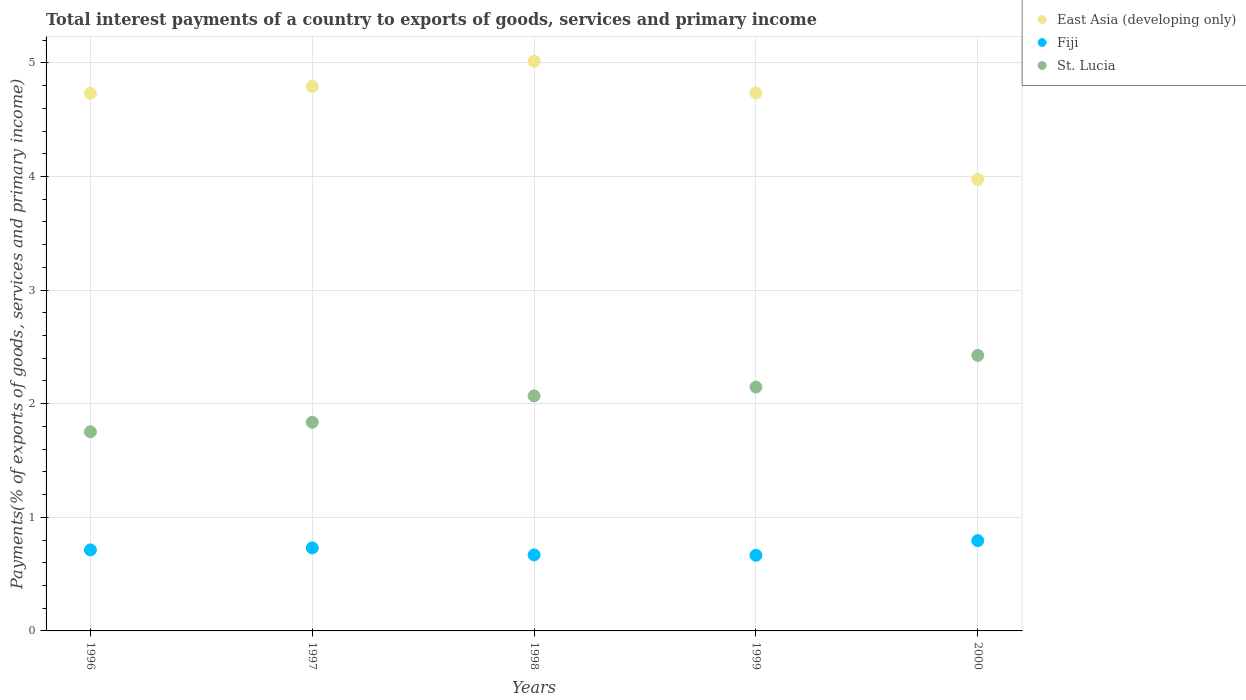What is the total interest payments in Fiji in 1996?
Your answer should be compact. 0.71. Across all years, what is the maximum total interest payments in Fiji?
Offer a very short reply. 0.79. Across all years, what is the minimum total interest payments in Fiji?
Your response must be concise. 0.67. In which year was the total interest payments in St. Lucia minimum?
Provide a short and direct response. 1996. What is the total total interest payments in Fiji in the graph?
Provide a succinct answer. 3.57. What is the difference between the total interest payments in St. Lucia in 1996 and that in 2000?
Your response must be concise. -0.67. What is the difference between the total interest payments in Fiji in 1998 and the total interest payments in St. Lucia in 1996?
Keep it short and to the point. -1.08. What is the average total interest payments in East Asia (developing only) per year?
Give a very brief answer. 4.65. In the year 1997, what is the difference between the total interest payments in East Asia (developing only) and total interest payments in Fiji?
Your answer should be compact. 4.06. What is the ratio of the total interest payments in East Asia (developing only) in 1996 to that in 1999?
Offer a very short reply. 1. Is the difference between the total interest payments in East Asia (developing only) in 1996 and 1999 greater than the difference between the total interest payments in Fiji in 1996 and 1999?
Ensure brevity in your answer.  No. What is the difference between the highest and the second highest total interest payments in Fiji?
Your answer should be very brief. 0.06. What is the difference between the highest and the lowest total interest payments in Fiji?
Your response must be concise. 0.13. In how many years, is the total interest payments in Fiji greater than the average total interest payments in Fiji taken over all years?
Your answer should be very brief. 2. Is it the case that in every year, the sum of the total interest payments in St. Lucia and total interest payments in East Asia (developing only)  is greater than the total interest payments in Fiji?
Your answer should be compact. Yes. Is the total interest payments in East Asia (developing only) strictly greater than the total interest payments in St. Lucia over the years?
Offer a terse response. Yes. How many dotlines are there?
Your answer should be very brief. 3. What is the difference between two consecutive major ticks on the Y-axis?
Your answer should be very brief. 1. Are the values on the major ticks of Y-axis written in scientific E-notation?
Make the answer very short. No. Does the graph contain any zero values?
Keep it short and to the point. No. Does the graph contain grids?
Offer a terse response. Yes. How many legend labels are there?
Make the answer very short. 3. What is the title of the graph?
Offer a terse response. Total interest payments of a country to exports of goods, services and primary income. Does "Low & middle income" appear as one of the legend labels in the graph?
Give a very brief answer. No. What is the label or title of the Y-axis?
Give a very brief answer. Payments(% of exports of goods, services and primary income). What is the Payments(% of exports of goods, services and primary income) in East Asia (developing only) in 1996?
Make the answer very short. 4.73. What is the Payments(% of exports of goods, services and primary income) of Fiji in 1996?
Provide a short and direct response. 0.71. What is the Payments(% of exports of goods, services and primary income) in St. Lucia in 1996?
Your answer should be compact. 1.75. What is the Payments(% of exports of goods, services and primary income) in East Asia (developing only) in 1997?
Offer a very short reply. 4.79. What is the Payments(% of exports of goods, services and primary income) in Fiji in 1997?
Your answer should be very brief. 0.73. What is the Payments(% of exports of goods, services and primary income) of St. Lucia in 1997?
Keep it short and to the point. 1.84. What is the Payments(% of exports of goods, services and primary income) of East Asia (developing only) in 1998?
Provide a succinct answer. 5.01. What is the Payments(% of exports of goods, services and primary income) in Fiji in 1998?
Provide a succinct answer. 0.67. What is the Payments(% of exports of goods, services and primary income) of St. Lucia in 1998?
Provide a short and direct response. 2.07. What is the Payments(% of exports of goods, services and primary income) of East Asia (developing only) in 1999?
Provide a short and direct response. 4.74. What is the Payments(% of exports of goods, services and primary income) in Fiji in 1999?
Offer a terse response. 0.67. What is the Payments(% of exports of goods, services and primary income) in St. Lucia in 1999?
Your answer should be compact. 2.15. What is the Payments(% of exports of goods, services and primary income) in East Asia (developing only) in 2000?
Ensure brevity in your answer.  3.97. What is the Payments(% of exports of goods, services and primary income) of Fiji in 2000?
Provide a succinct answer. 0.79. What is the Payments(% of exports of goods, services and primary income) in St. Lucia in 2000?
Offer a terse response. 2.43. Across all years, what is the maximum Payments(% of exports of goods, services and primary income) of East Asia (developing only)?
Provide a succinct answer. 5.01. Across all years, what is the maximum Payments(% of exports of goods, services and primary income) in Fiji?
Offer a very short reply. 0.79. Across all years, what is the maximum Payments(% of exports of goods, services and primary income) in St. Lucia?
Offer a very short reply. 2.43. Across all years, what is the minimum Payments(% of exports of goods, services and primary income) of East Asia (developing only)?
Provide a succinct answer. 3.97. Across all years, what is the minimum Payments(% of exports of goods, services and primary income) of Fiji?
Your answer should be compact. 0.67. Across all years, what is the minimum Payments(% of exports of goods, services and primary income) in St. Lucia?
Offer a terse response. 1.75. What is the total Payments(% of exports of goods, services and primary income) in East Asia (developing only) in the graph?
Ensure brevity in your answer.  23.25. What is the total Payments(% of exports of goods, services and primary income) in Fiji in the graph?
Provide a succinct answer. 3.57. What is the total Payments(% of exports of goods, services and primary income) of St. Lucia in the graph?
Your response must be concise. 10.23. What is the difference between the Payments(% of exports of goods, services and primary income) of East Asia (developing only) in 1996 and that in 1997?
Give a very brief answer. -0.06. What is the difference between the Payments(% of exports of goods, services and primary income) of Fiji in 1996 and that in 1997?
Make the answer very short. -0.02. What is the difference between the Payments(% of exports of goods, services and primary income) of St. Lucia in 1996 and that in 1997?
Give a very brief answer. -0.08. What is the difference between the Payments(% of exports of goods, services and primary income) in East Asia (developing only) in 1996 and that in 1998?
Make the answer very short. -0.28. What is the difference between the Payments(% of exports of goods, services and primary income) in Fiji in 1996 and that in 1998?
Your response must be concise. 0.04. What is the difference between the Payments(% of exports of goods, services and primary income) of St. Lucia in 1996 and that in 1998?
Ensure brevity in your answer.  -0.32. What is the difference between the Payments(% of exports of goods, services and primary income) in East Asia (developing only) in 1996 and that in 1999?
Make the answer very short. -0. What is the difference between the Payments(% of exports of goods, services and primary income) in Fiji in 1996 and that in 1999?
Your response must be concise. 0.05. What is the difference between the Payments(% of exports of goods, services and primary income) in St. Lucia in 1996 and that in 1999?
Your answer should be very brief. -0.39. What is the difference between the Payments(% of exports of goods, services and primary income) in East Asia (developing only) in 1996 and that in 2000?
Give a very brief answer. 0.76. What is the difference between the Payments(% of exports of goods, services and primary income) in Fiji in 1996 and that in 2000?
Ensure brevity in your answer.  -0.08. What is the difference between the Payments(% of exports of goods, services and primary income) of St. Lucia in 1996 and that in 2000?
Your response must be concise. -0.67. What is the difference between the Payments(% of exports of goods, services and primary income) in East Asia (developing only) in 1997 and that in 1998?
Ensure brevity in your answer.  -0.22. What is the difference between the Payments(% of exports of goods, services and primary income) in Fiji in 1997 and that in 1998?
Your answer should be compact. 0.06. What is the difference between the Payments(% of exports of goods, services and primary income) of St. Lucia in 1997 and that in 1998?
Ensure brevity in your answer.  -0.23. What is the difference between the Payments(% of exports of goods, services and primary income) of East Asia (developing only) in 1997 and that in 1999?
Offer a terse response. 0.06. What is the difference between the Payments(% of exports of goods, services and primary income) of Fiji in 1997 and that in 1999?
Provide a short and direct response. 0.07. What is the difference between the Payments(% of exports of goods, services and primary income) of St. Lucia in 1997 and that in 1999?
Your answer should be very brief. -0.31. What is the difference between the Payments(% of exports of goods, services and primary income) in East Asia (developing only) in 1997 and that in 2000?
Keep it short and to the point. 0.82. What is the difference between the Payments(% of exports of goods, services and primary income) of Fiji in 1997 and that in 2000?
Give a very brief answer. -0.06. What is the difference between the Payments(% of exports of goods, services and primary income) of St. Lucia in 1997 and that in 2000?
Your response must be concise. -0.59. What is the difference between the Payments(% of exports of goods, services and primary income) in East Asia (developing only) in 1998 and that in 1999?
Your response must be concise. 0.28. What is the difference between the Payments(% of exports of goods, services and primary income) in Fiji in 1998 and that in 1999?
Give a very brief answer. 0. What is the difference between the Payments(% of exports of goods, services and primary income) in St. Lucia in 1998 and that in 1999?
Your response must be concise. -0.08. What is the difference between the Payments(% of exports of goods, services and primary income) in East Asia (developing only) in 1998 and that in 2000?
Give a very brief answer. 1.04. What is the difference between the Payments(% of exports of goods, services and primary income) in Fiji in 1998 and that in 2000?
Your response must be concise. -0.13. What is the difference between the Payments(% of exports of goods, services and primary income) in St. Lucia in 1998 and that in 2000?
Keep it short and to the point. -0.36. What is the difference between the Payments(% of exports of goods, services and primary income) of East Asia (developing only) in 1999 and that in 2000?
Your response must be concise. 0.76. What is the difference between the Payments(% of exports of goods, services and primary income) of Fiji in 1999 and that in 2000?
Ensure brevity in your answer.  -0.13. What is the difference between the Payments(% of exports of goods, services and primary income) in St. Lucia in 1999 and that in 2000?
Your answer should be compact. -0.28. What is the difference between the Payments(% of exports of goods, services and primary income) of East Asia (developing only) in 1996 and the Payments(% of exports of goods, services and primary income) of Fiji in 1997?
Your response must be concise. 4. What is the difference between the Payments(% of exports of goods, services and primary income) of East Asia (developing only) in 1996 and the Payments(% of exports of goods, services and primary income) of St. Lucia in 1997?
Ensure brevity in your answer.  2.9. What is the difference between the Payments(% of exports of goods, services and primary income) of Fiji in 1996 and the Payments(% of exports of goods, services and primary income) of St. Lucia in 1997?
Provide a succinct answer. -1.12. What is the difference between the Payments(% of exports of goods, services and primary income) in East Asia (developing only) in 1996 and the Payments(% of exports of goods, services and primary income) in Fiji in 1998?
Keep it short and to the point. 4.06. What is the difference between the Payments(% of exports of goods, services and primary income) of East Asia (developing only) in 1996 and the Payments(% of exports of goods, services and primary income) of St. Lucia in 1998?
Your response must be concise. 2.66. What is the difference between the Payments(% of exports of goods, services and primary income) of Fiji in 1996 and the Payments(% of exports of goods, services and primary income) of St. Lucia in 1998?
Your response must be concise. -1.36. What is the difference between the Payments(% of exports of goods, services and primary income) of East Asia (developing only) in 1996 and the Payments(% of exports of goods, services and primary income) of Fiji in 1999?
Offer a terse response. 4.07. What is the difference between the Payments(% of exports of goods, services and primary income) of East Asia (developing only) in 1996 and the Payments(% of exports of goods, services and primary income) of St. Lucia in 1999?
Your answer should be very brief. 2.59. What is the difference between the Payments(% of exports of goods, services and primary income) in Fiji in 1996 and the Payments(% of exports of goods, services and primary income) in St. Lucia in 1999?
Provide a succinct answer. -1.43. What is the difference between the Payments(% of exports of goods, services and primary income) in East Asia (developing only) in 1996 and the Payments(% of exports of goods, services and primary income) in Fiji in 2000?
Offer a very short reply. 3.94. What is the difference between the Payments(% of exports of goods, services and primary income) in East Asia (developing only) in 1996 and the Payments(% of exports of goods, services and primary income) in St. Lucia in 2000?
Provide a succinct answer. 2.31. What is the difference between the Payments(% of exports of goods, services and primary income) in Fiji in 1996 and the Payments(% of exports of goods, services and primary income) in St. Lucia in 2000?
Your answer should be very brief. -1.71. What is the difference between the Payments(% of exports of goods, services and primary income) in East Asia (developing only) in 1997 and the Payments(% of exports of goods, services and primary income) in Fiji in 1998?
Offer a very short reply. 4.12. What is the difference between the Payments(% of exports of goods, services and primary income) of East Asia (developing only) in 1997 and the Payments(% of exports of goods, services and primary income) of St. Lucia in 1998?
Keep it short and to the point. 2.72. What is the difference between the Payments(% of exports of goods, services and primary income) in Fiji in 1997 and the Payments(% of exports of goods, services and primary income) in St. Lucia in 1998?
Ensure brevity in your answer.  -1.34. What is the difference between the Payments(% of exports of goods, services and primary income) in East Asia (developing only) in 1997 and the Payments(% of exports of goods, services and primary income) in Fiji in 1999?
Ensure brevity in your answer.  4.13. What is the difference between the Payments(% of exports of goods, services and primary income) in East Asia (developing only) in 1997 and the Payments(% of exports of goods, services and primary income) in St. Lucia in 1999?
Ensure brevity in your answer.  2.65. What is the difference between the Payments(% of exports of goods, services and primary income) in Fiji in 1997 and the Payments(% of exports of goods, services and primary income) in St. Lucia in 1999?
Your answer should be compact. -1.42. What is the difference between the Payments(% of exports of goods, services and primary income) of East Asia (developing only) in 1997 and the Payments(% of exports of goods, services and primary income) of Fiji in 2000?
Your answer should be very brief. 4. What is the difference between the Payments(% of exports of goods, services and primary income) in East Asia (developing only) in 1997 and the Payments(% of exports of goods, services and primary income) in St. Lucia in 2000?
Provide a succinct answer. 2.37. What is the difference between the Payments(% of exports of goods, services and primary income) of Fiji in 1997 and the Payments(% of exports of goods, services and primary income) of St. Lucia in 2000?
Give a very brief answer. -1.69. What is the difference between the Payments(% of exports of goods, services and primary income) of East Asia (developing only) in 1998 and the Payments(% of exports of goods, services and primary income) of Fiji in 1999?
Give a very brief answer. 4.35. What is the difference between the Payments(% of exports of goods, services and primary income) of East Asia (developing only) in 1998 and the Payments(% of exports of goods, services and primary income) of St. Lucia in 1999?
Give a very brief answer. 2.87. What is the difference between the Payments(% of exports of goods, services and primary income) in Fiji in 1998 and the Payments(% of exports of goods, services and primary income) in St. Lucia in 1999?
Provide a short and direct response. -1.48. What is the difference between the Payments(% of exports of goods, services and primary income) in East Asia (developing only) in 1998 and the Payments(% of exports of goods, services and primary income) in Fiji in 2000?
Provide a succinct answer. 4.22. What is the difference between the Payments(% of exports of goods, services and primary income) in East Asia (developing only) in 1998 and the Payments(% of exports of goods, services and primary income) in St. Lucia in 2000?
Make the answer very short. 2.59. What is the difference between the Payments(% of exports of goods, services and primary income) of Fiji in 1998 and the Payments(% of exports of goods, services and primary income) of St. Lucia in 2000?
Your answer should be compact. -1.76. What is the difference between the Payments(% of exports of goods, services and primary income) of East Asia (developing only) in 1999 and the Payments(% of exports of goods, services and primary income) of Fiji in 2000?
Your answer should be very brief. 3.94. What is the difference between the Payments(% of exports of goods, services and primary income) in East Asia (developing only) in 1999 and the Payments(% of exports of goods, services and primary income) in St. Lucia in 2000?
Your answer should be very brief. 2.31. What is the difference between the Payments(% of exports of goods, services and primary income) in Fiji in 1999 and the Payments(% of exports of goods, services and primary income) in St. Lucia in 2000?
Your answer should be very brief. -1.76. What is the average Payments(% of exports of goods, services and primary income) in East Asia (developing only) per year?
Your answer should be compact. 4.65. What is the average Payments(% of exports of goods, services and primary income) of Fiji per year?
Ensure brevity in your answer.  0.71. What is the average Payments(% of exports of goods, services and primary income) of St. Lucia per year?
Provide a succinct answer. 2.05. In the year 1996, what is the difference between the Payments(% of exports of goods, services and primary income) in East Asia (developing only) and Payments(% of exports of goods, services and primary income) in Fiji?
Your answer should be very brief. 4.02. In the year 1996, what is the difference between the Payments(% of exports of goods, services and primary income) in East Asia (developing only) and Payments(% of exports of goods, services and primary income) in St. Lucia?
Your response must be concise. 2.98. In the year 1996, what is the difference between the Payments(% of exports of goods, services and primary income) of Fiji and Payments(% of exports of goods, services and primary income) of St. Lucia?
Provide a succinct answer. -1.04. In the year 1997, what is the difference between the Payments(% of exports of goods, services and primary income) of East Asia (developing only) and Payments(% of exports of goods, services and primary income) of Fiji?
Your answer should be very brief. 4.06. In the year 1997, what is the difference between the Payments(% of exports of goods, services and primary income) in East Asia (developing only) and Payments(% of exports of goods, services and primary income) in St. Lucia?
Keep it short and to the point. 2.96. In the year 1997, what is the difference between the Payments(% of exports of goods, services and primary income) of Fiji and Payments(% of exports of goods, services and primary income) of St. Lucia?
Offer a very short reply. -1.11. In the year 1998, what is the difference between the Payments(% of exports of goods, services and primary income) of East Asia (developing only) and Payments(% of exports of goods, services and primary income) of Fiji?
Your answer should be very brief. 4.35. In the year 1998, what is the difference between the Payments(% of exports of goods, services and primary income) of East Asia (developing only) and Payments(% of exports of goods, services and primary income) of St. Lucia?
Offer a terse response. 2.95. In the year 1998, what is the difference between the Payments(% of exports of goods, services and primary income) of Fiji and Payments(% of exports of goods, services and primary income) of St. Lucia?
Provide a short and direct response. -1.4. In the year 1999, what is the difference between the Payments(% of exports of goods, services and primary income) in East Asia (developing only) and Payments(% of exports of goods, services and primary income) in Fiji?
Keep it short and to the point. 4.07. In the year 1999, what is the difference between the Payments(% of exports of goods, services and primary income) in East Asia (developing only) and Payments(% of exports of goods, services and primary income) in St. Lucia?
Provide a short and direct response. 2.59. In the year 1999, what is the difference between the Payments(% of exports of goods, services and primary income) in Fiji and Payments(% of exports of goods, services and primary income) in St. Lucia?
Offer a very short reply. -1.48. In the year 2000, what is the difference between the Payments(% of exports of goods, services and primary income) in East Asia (developing only) and Payments(% of exports of goods, services and primary income) in Fiji?
Give a very brief answer. 3.18. In the year 2000, what is the difference between the Payments(% of exports of goods, services and primary income) in East Asia (developing only) and Payments(% of exports of goods, services and primary income) in St. Lucia?
Ensure brevity in your answer.  1.55. In the year 2000, what is the difference between the Payments(% of exports of goods, services and primary income) in Fiji and Payments(% of exports of goods, services and primary income) in St. Lucia?
Offer a terse response. -1.63. What is the ratio of the Payments(% of exports of goods, services and primary income) of East Asia (developing only) in 1996 to that in 1997?
Give a very brief answer. 0.99. What is the ratio of the Payments(% of exports of goods, services and primary income) in Fiji in 1996 to that in 1997?
Your response must be concise. 0.98. What is the ratio of the Payments(% of exports of goods, services and primary income) in St. Lucia in 1996 to that in 1997?
Provide a short and direct response. 0.95. What is the ratio of the Payments(% of exports of goods, services and primary income) in East Asia (developing only) in 1996 to that in 1998?
Offer a terse response. 0.94. What is the ratio of the Payments(% of exports of goods, services and primary income) of Fiji in 1996 to that in 1998?
Give a very brief answer. 1.07. What is the ratio of the Payments(% of exports of goods, services and primary income) of St. Lucia in 1996 to that in 1998?
Your answer should be compact. 0.85. What is the ratio of the Payments(% of exports of goods, services and primary income) in Fiji in 1996 to that in 1999?
Provide a succinct answer. 1.07. What is the ratio of the Payments(% of exports of goods, services and primary income) in St. Lucia in 1996 to that in 1999?
Offer a very short reply. 0.82. What is the ratio of the Payments(% of exports of goods, services and primary income) in East Asia (developing only) in 1996 to that in 2000?
Keep it short and to the point. 1.19. What is the ratio of the Payments(% of exports of goods, services and primary income) of Fiji in 1996 to that in 2000?
Provide a succinct answer. 0.9. What is the ratio of the Payments(% of exports of goods, services and primary income) in St. Lucia in 1996 to that in 2000?
Keep it short and to the point. 0.72. What is the ratio of the Payments(% of exports of goods, services and primary income) of East Asia (developing only) in 1997 to that in 1998?
Your answer should be very brief. 0.96. What is the ratio of the Payments(% of exports of goods, services and primary income) of Fiji in 1997 to that in 1998?
Ensure brevity in your answer.  1.09. What is the ratio of the Payments(% of exports of goods, services and primary income) in St. Lucia in 1997 to that in 1998?
Your answer should be compact. 0.89. What is the ratio of the Payments(% of exports of goods, services and primary income) of Fiji in 1997 to that in 1999?
Make the answer very short. 1.1. What is the ratio of the Payments(% of exports of goods, services and primary income) of St. Lucia in 1997 to that in 1999?
Your answer should be very brief. 0.86. What is the ratio of the Payments(% of exports of goods, services and primary income) of East Asia (developing only) in 1997 to that in 2000?
Ensure brevity in your answer.  1.21. What is the ratio of the Payments(% of exports of goods, services and primary income) in Fiji in 1997 to that in 2000?
Make the answer very short. 0.92. What is the ratio of the Payments(% of exports of goods, services and primary income) in St. Lucia in 1997 to that in 2000?
Your answer should be very brief. 0.76. What is the ratio of the Payments(% of exports of goods, services and primary income) in East Asia (developing only) in 1998 to that in 1999?
Provide a succinct answer. 1.06. What is the ratio of the Payments(% of exports of goods, services and primary income) of Fiji in 1998 to that in 1999?
Make the answer very short. 1. What is the ratio of the Payments(% of exports of goods, services and primary income) of St. Lucia in 1998 to that in 1999?
Your answer should be very brief. 0.96. What is the ratio of the Payments(% of exports of goods, services and primary income) in East Asia (developing only) in 1998 to that in 2000?
Provide a succinct answer. 1.26. What is the ratio of the Payments(% of exports of goods, services and primary income) of Fiji in 1998 to that in 2000?
Ensure brevity in your answer.  0.84. What is the ratio of the Payments(% of exports of goods, services and primary income) in St. Lucia in 1998 to that in 2000?
Your answer should be compact. 0.85. What is the ratio of the Payments(% of exports of goods, services and primary income) in East Asia (developing only) in 1999 to that in 2000?
Ensure brevity in your answer.  1.19. What is the ratio of the Payments(% of exports of goods, services and primary income) in Fiji in 1999 to that in 2000?
Make the answer very short. 0.84. What is the ratio of the Payments(% of exports of goods, services and primary income) in St. Lucia in 1999 to that in 2000?
Offer a very short reply. 0.89. What is the difference between the highest and the second highest Payments(% of exports of goods, services and primary income) of East Asia (developing only)?
Offer a terse response. 0.22. What is the difference between the highest and the second highest Payments(% of exports of goods, services and primary income) in Fiji?
Ensure brevity in your answer.  0.06. What is the difference between the highest and the second highest Payments(% of exports of goods, services and primary income) in St. Lucia?
Offer a terse response. 0.28. What is the difference between the highest and the lowest Payments(% of exports of goods, services and primary income) of East Asia (developing only)?
Offer a very short reply. 1.04. What is the difference between the highest and the lowest Payments(% of exports of goods, services and primary income) in Fiji?
Give a very brief answer. 0.13. What is the difference between the highest and the lowest Payments(% of exports of goods, services and primary income) of St. Lucia?
Provide a short and direct response. 0.67. 